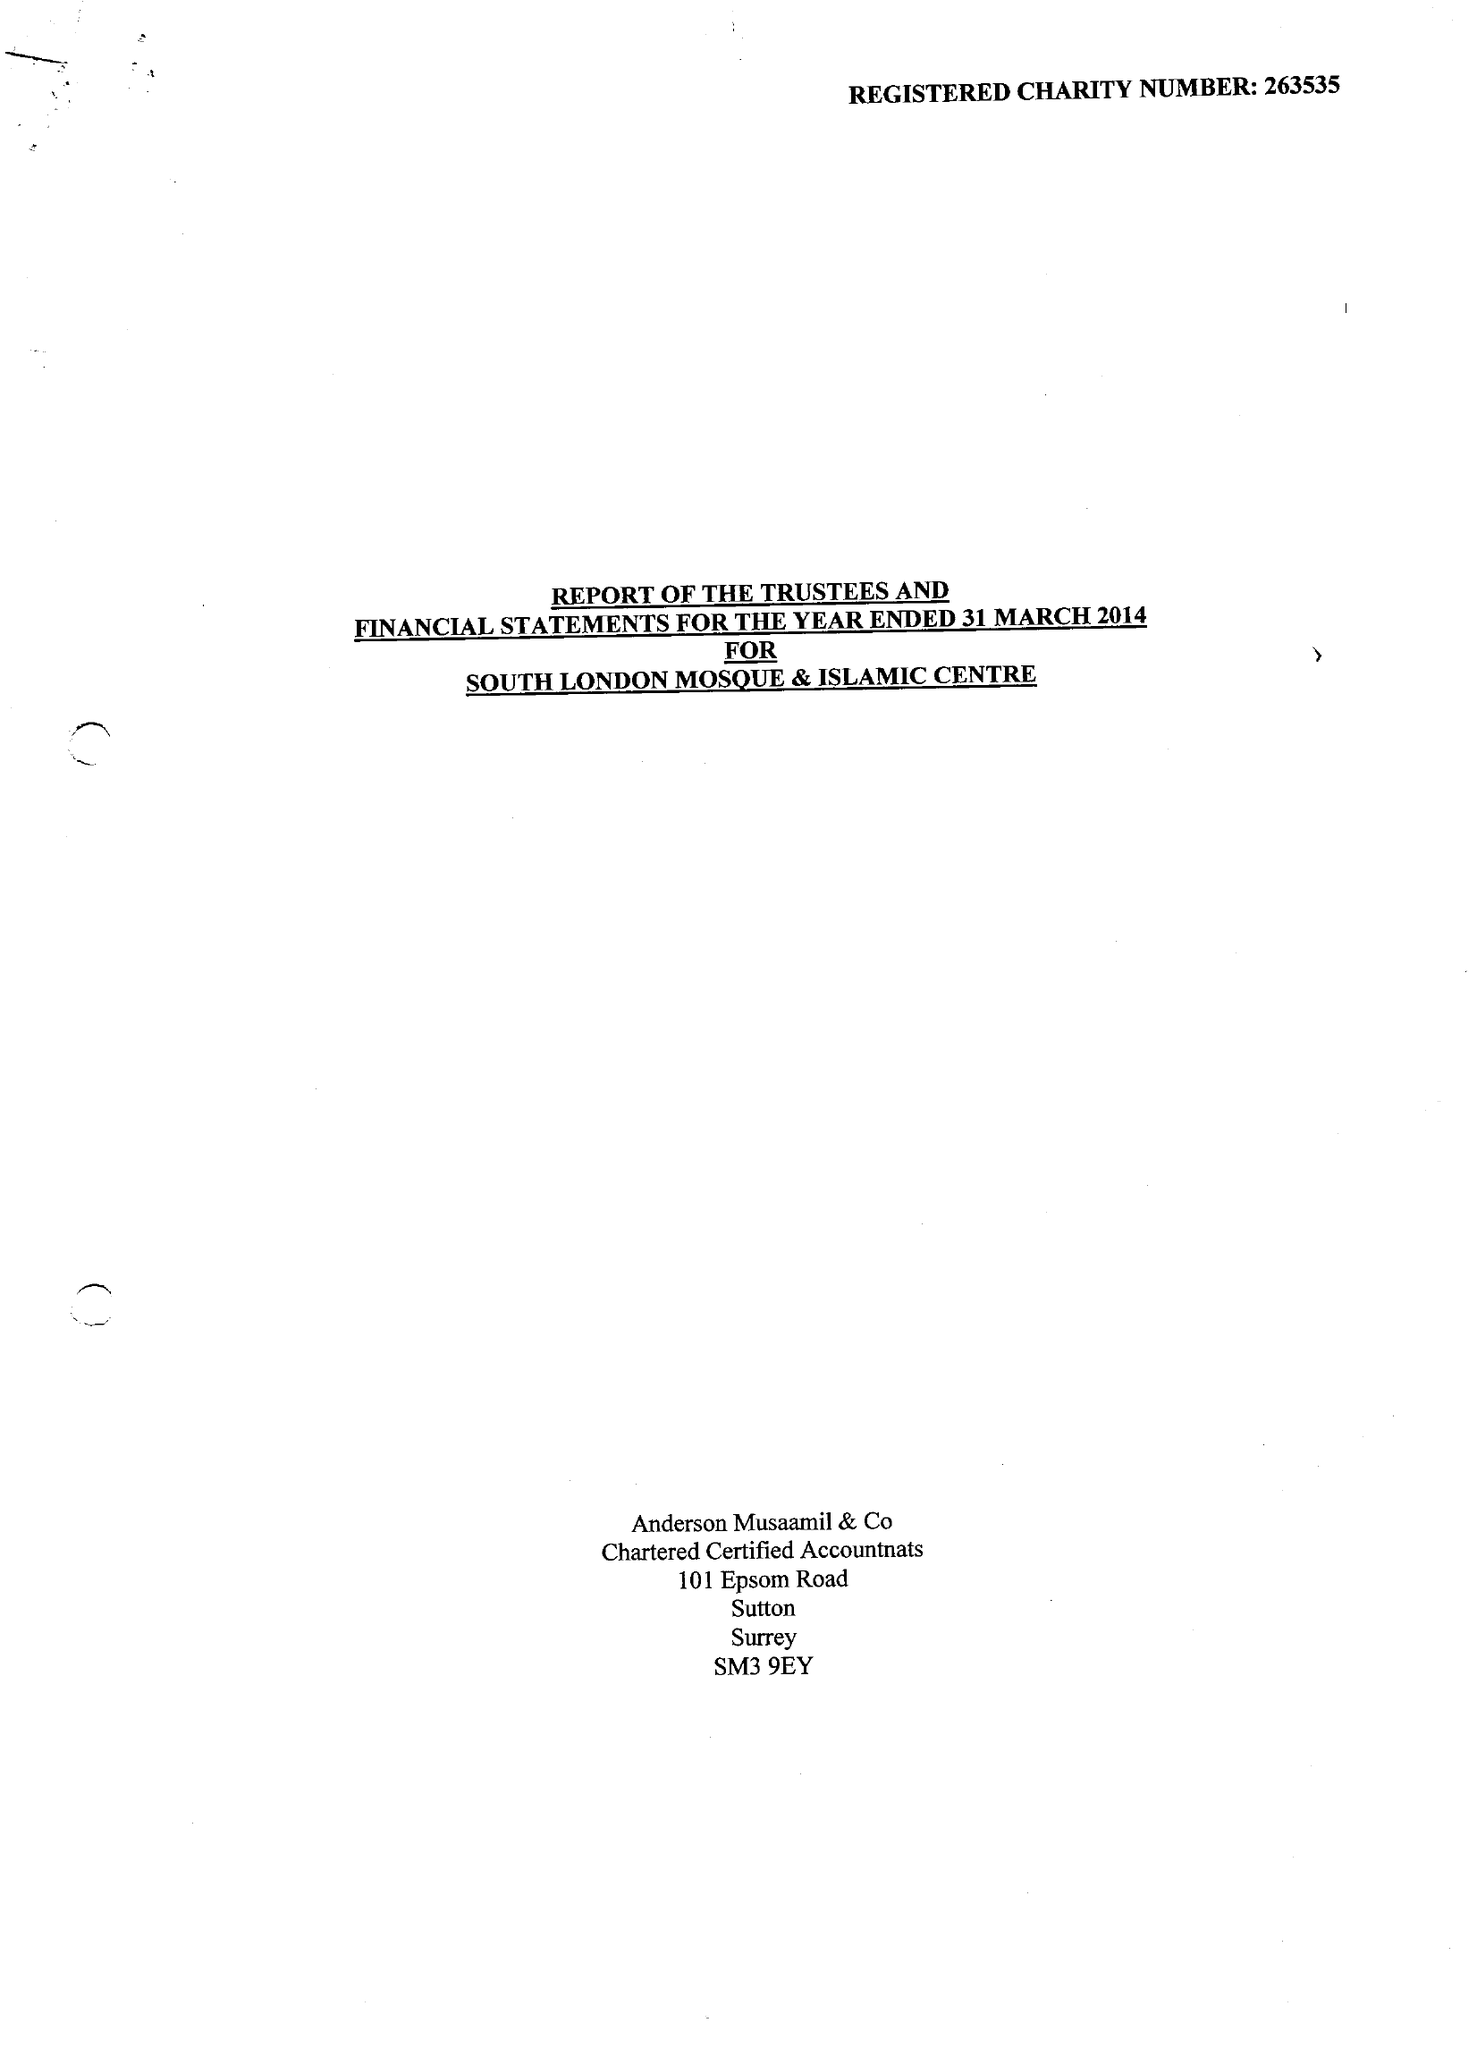What is the value for the address__postcode?
Answer the question using a single word or phrase. SW16 6NN 